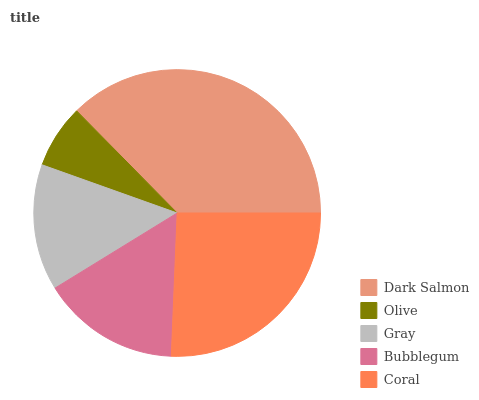Is Olive the minimum?
Answer yes or no. Yes. Is Dark Salmon the maximum?
Answer yes or no. Yes. Is Gray the minimum?
Answer yes or no. No. Is Gray the maximum?
Answer yes or no. No. Is Gray greater than Olive?
Answer yes or no. Yes. Is Olive less than Gray?
Answer yes or no. Yes. Is Olive greater than Gray?
Answer yes or no. No. Is Gray less than Olive?
Answer yes or no. No. Is Bubblegum the high median?
Answer yes or no. Yes. Is Bubblegum the low median?
Answer yes or no. Yes. Is Olive the high median?
Answer yes or no. No. Is Dark Salmon the low median?
Answer yes or no. No. 